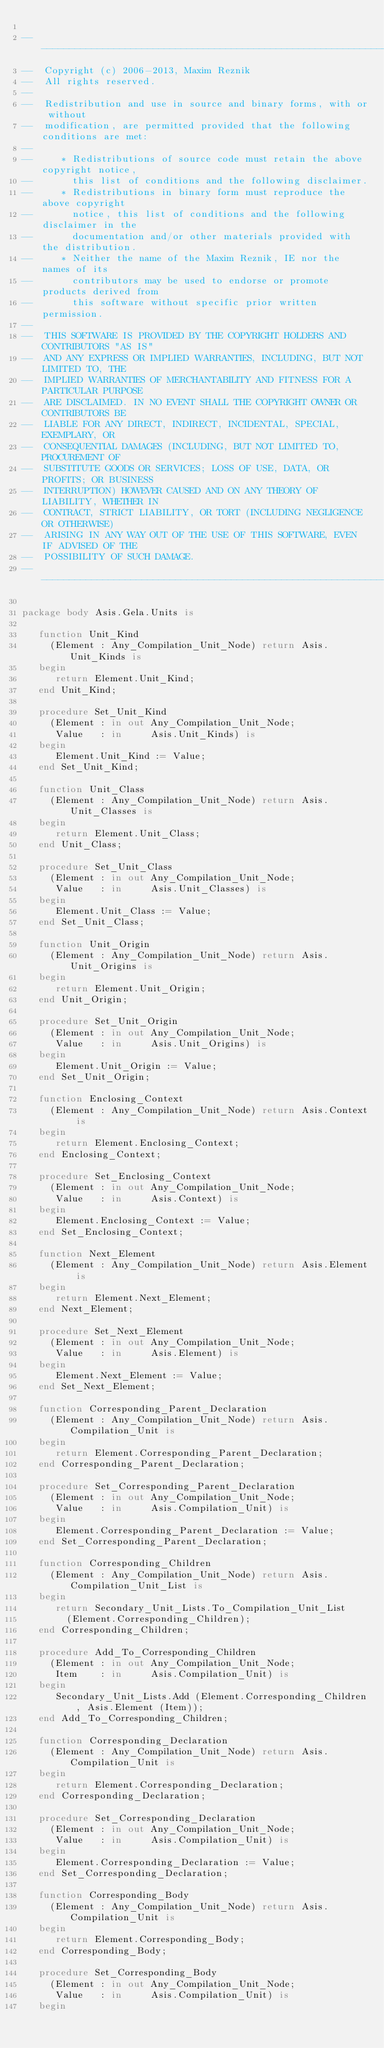<code> <loc_0><loc_0><loc_500><loc_500><_Ada_>
------------------------------------------------------------------------------
--  Copyright (c) 2006-2013, Maxim Reznik
--  All rights reserved.
--
--  Redistribution and use in source and binary forms, with or without
--  modification, are permitted provided that the following conditions are met:
--
--     * Redistributions of source code must retain the above copyright notice,
--       this list of conditions and the following disclaimer.
--     * Redistributions in binary form must reproduce the above copyright
--       notice, this list of conditions and the following disclaimer in the
--       documentation and/or other materials provided with the distribution.
--     * Neither the name of the Maxim Reznik, IE nor the names of its
--       contributors may be used to endorse or promote products derived from
--       this software without specific prior written permission.
--
--  THIS SOFTWARE IS PROVIDED BY THE COPYRIGHT HOLDERS AND CONTRIBUTORS "AS IS"
--  AND ANY EXPRESS OR IMPLIED WARRANTIES, INCLUDING, BUT NOT LIMITED TO, THE
--  IMPLIED WARRANTIES OF MERCHANTABILITY AND FITNESS FOR A PARTICULAR PURPOSE
--  ARE DISCLAIMED. IN NO EVENT SHALL THE COPYRIGHT OWNER OR CONTRIBUTORS BE
--  LIABLE FOR ANY DIRECT, INDIRECT, INCIDENTAL, SPECIAL, EXEMPLARY, OR
--  CONSEQUENTIAL DAMAGES (INCLUDING, BUT NOT LIMITED TO, PROCUREMENT OF
--  SUBSTITUTE GOODS OR SERVICES; LOSS OF USE, DATA, OR PROFITS; OR BUSINESS
--  INTERRUPTION) HOWEVER CAUSED AND ON ANY THEORY OF LIABILITY, WHETHER IN
--  CONTRACT, STRICT LIABILITY, OR TORT (INCLUDING NEGLIGENCE OR OTHERWISE)
--  ARISING IN ANY WAY OUT OF THE USE OF THIS SOFTWARE, EVEN IF ADVISED OF THE
--  POSSIBILITY OF SUCH DAMAGE.
------------------------------------------------------------------------------

package body Asis.Gela.Units is

   function Unit_Kind
     (Element : Any_Compilation_Unit_Node) return Asis.Unit_Kinds is
   begin
      return Element.Unit_Kind;
   end Unit_Kind;

   procedure Set_Unit_Kind
     (Element : in out Any_Compilation_Unit_Node;
      Value   : in     Asis.Unit_Kinds) is
   begin
      Element.Unit_Kind := Value;
   end Set_Unit_Kind;

   function Unit_Class
     (Element : Any_Compilation_Unit_Node) return Asis.Unit_Classes is
   begin
      return Element.Unit_Class;
   end Unit_Class;

   procedure Set_Unit_Class
     (Element : in out Any_Compilation_Unit_Node;
      Value   : in     Asis.Unit_Classes) is
   begin
      Element.Unit_Class := Value;
   end Set_Unit_Class;

   function Unit_Origin
     (Element : Any_Compilation_Unit_Node) return Asis.Unit_Origins is
   begin
      return Element.Unit_Origin;
   end Unit_Origin;

   procedure Set_Unit_Origin
     (Element : in out Any_Compilation_Unit_Node;
      Value   : in     Asis.Unit_Origins) is
   begin
      Element.Unit_Origin := Value;
   end Set_Unit_Origin;

   function Enclosing_Context
     (Element : Any_Compilation_Unit_Node) return Asis.Context is
   begin
      return Element.Enclosing_Context;
   end Enclosing_Context;

   procedure Set_Enclosing_Context
     (Element : in out Any_Compilation_Unit_Node;
      Value   : in     Asis.Context) is
   begin
      Element.Enclosing_Context := Value;
   end Set_Enclosing_Context;

   function Next_Element
     (Element : Any_Compilation_Unit_Node) return Asis.Element is
   begin
      return Element.Next_Element;
   end Next_Element;

   procedure Set_Next_Element
     (Element : in out Any_Compilation_Unit_Node;
      Value   : in     Asis.Element) is
   begin
      Element.Next_Element := Value;
   end Set_Next_Element;

   function Corresponding_Parent_Declaration
     (Element : Any_Compilation_Unit_Node) return Asis.Compilation_Unit is
   begin
      return Element.Corresponding_Parent_Declaration;
   end Corresponding_Parent_Declaration;

   procedure Set_Corresponding_Parent_Declaration
     (Element : in out Any_Compilation_Unit_Node;
      Value   : in     Asis.Compilation_Unit) is
   begin
      Element.Corresponding_Parent_Declaration := Value;
   end Set_Corresponding_Parent_Declaration;

   function Corresponding_Children
     (Element : Any_Compilation_Unit_Node) return Asis.Compilation_Unit_List is
   begin
      return Secondary_Unit_Lists.To_Compilation_Unit_List
        (Element.Corresponding_Children);
   end Corresponding_Children;

   procedure Add_To_Corresponding_Children
     (Element : in out Any_Compilation_Unit_Node;
      Item    : in     Asis.Compilation_Unit) is
   begin
      Secondary_Unit_Lists.Add (Element.Corresponding_Children, Asis.Element (Item));
   end Add_To_Corresponding_Children;

   function Corresponding_Declaration
     (Element : Any_Compilation_Unit_Node) return Asis.Compilation_Unit is
   begin
      return Element.Corresponding_Declaration;
   end Corresponding_Declaration;

   procedure Set_Corresponding_Declaration
     (Element : in out Any_Compilation_Unit_Node;
      Value   : in     Asis.Compilation_Unit) is
   begin
      Element.Corresponding_Declaration := Value;
   end Set_Corresponding_Declaration;

   function Corresponding_Body
     (Element : Any_Compilation_Unit_Node) return Asis.Compilation_Unit is
   begin
      return Element.Corresponding_Body;
   end Corresponding_Body;

   procedure Set_Corresponding_Body
     (Element : in out Any_Compilation_Unit_Node;
      Value   : in     Asis.Compilation_Unit) is
   begin</code> 